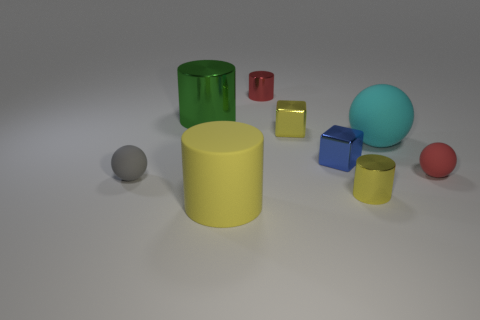What is the size of the metallic block that is the same color as the matte cylinder?
Provide a short and direct response. Small. There is a rubber thing that is the same size as the gray ball; what is its color?
Provide a succinct answer. Red. Are there fewer big yellow cylinders behind the cyan rubber object than large things behind the small yellow shiny cylinder?
Offer a terse response. Yes. Is the size of the metal cylinder that is right of the red cylinder the same as the large cyan matte sphere?
Your answer should be compact. No. The small shiny thing that is on the left side of the tiny yellow shiny cube has what shape?
Offer a very short reply. Cylinder. Is the number of blue rubber objects greater than the number of shiny things?
Your response must be concise. No. There is a tiny object in front of the gray object; is its color the same as the rubber cylinder?
Give a very brief answer. Yes. How many things are either tiny yellow metal cubes behind the cyan sphere or big cylinders that are in front of the large cyan rubber ball?
Give a very brief answer. 2. What number of metallic cylinders are in front of the small yellow metallic block and behind the green shiny object?
Your answer should be compact. 0. Is the material of the small gray thing the same as the big cyan thing?
Your answer should be compact. Yes. 